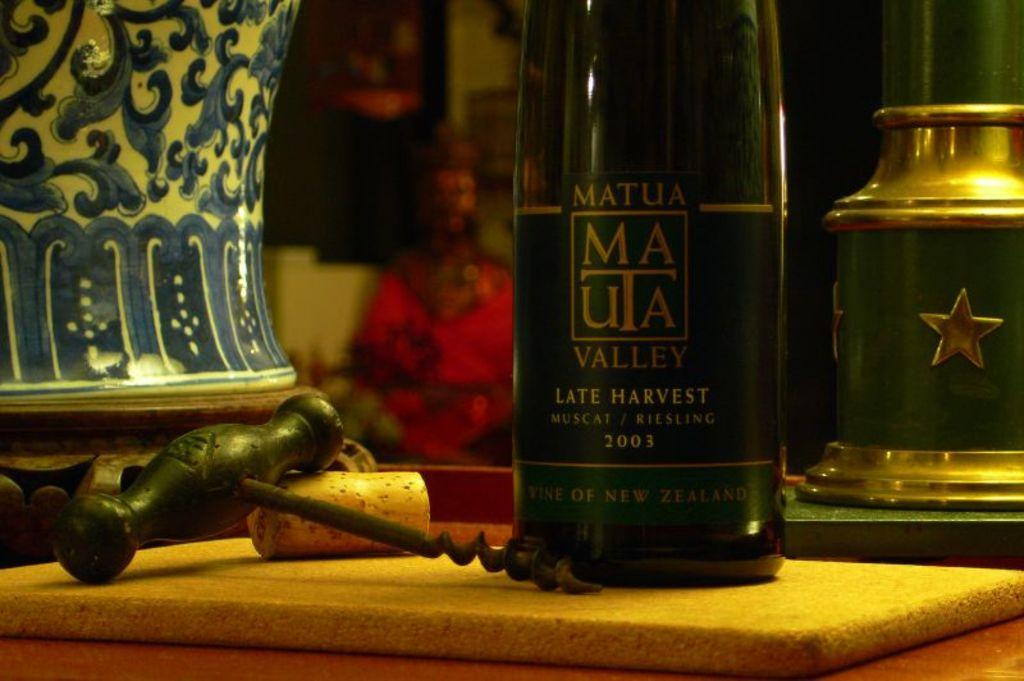<image>
Render a clear and concise summary of the photo. A bottle of "LATE HARVEST" is on the table. 